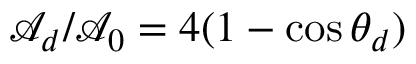Convert formula to latex. <formula><loc_0><loc_0><loc_500><loc_500>\mathcal { A } _ { d } / \mathcal { A } _ { 0 } = 4 ( 1 - \cos \theta _ { d } )</formula> 